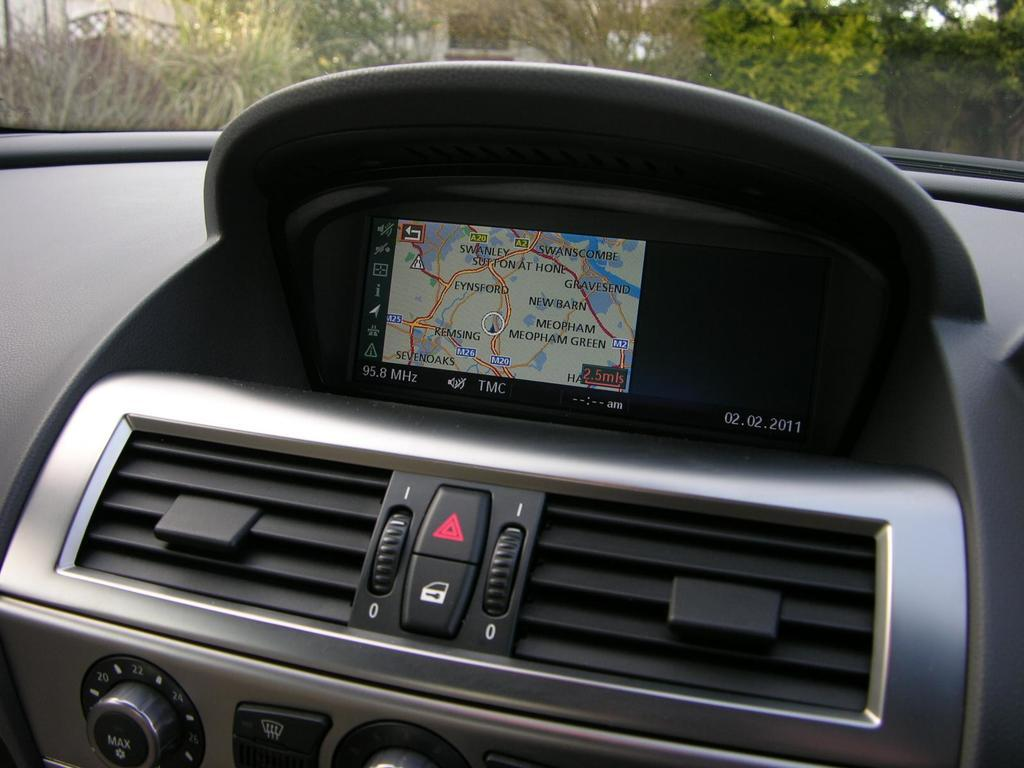What is the setting of the image? The image shows the inside of a car. What can be seen outside the car through the windows? There are many trees visible in the image. What type of technology is present in the car? There is a digital screen in the car. What feature allows the driver to adjust the sound system? There are tuners in the car. What type of meat is being cooked over the fire in the image? There is no meat or fire present in the image; it shows the inside of a car. 